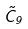<formula> <loc_0><loc_0><loc_500><loc_500>\tilde { C } _ { 9 }</formula> 